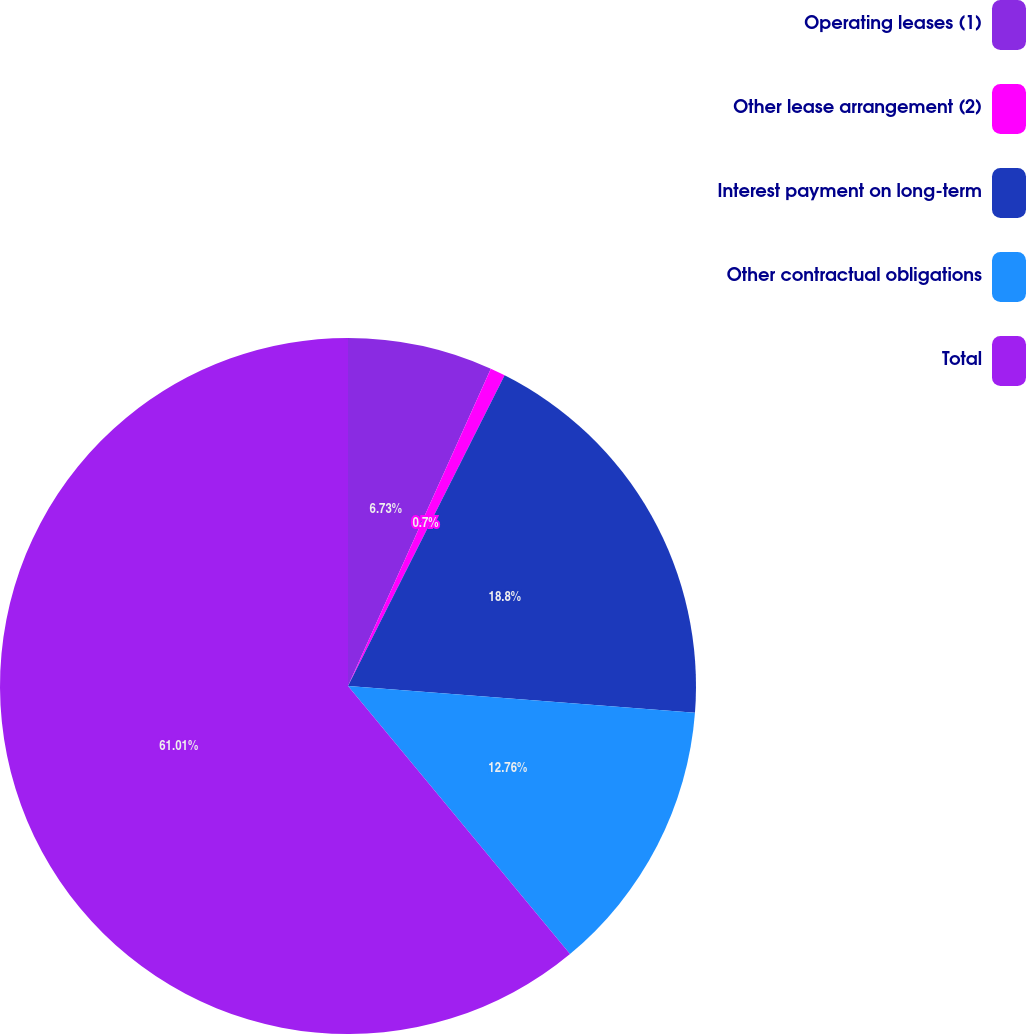Convert chart. <chart><loc_0><loc_0><loc_500><loc_500><pie_chart><fcel>Operating leases (1)<fcel>Other lease arrangement (2)<fcel>Interest payment on long-term<fcel>Other contractual obligations<fcel>Total<nl><fcel>6.73%<fcel>0.7%<fcel>18.79%<fcel>12.76%<fcel>61.0%<nl></chart> 